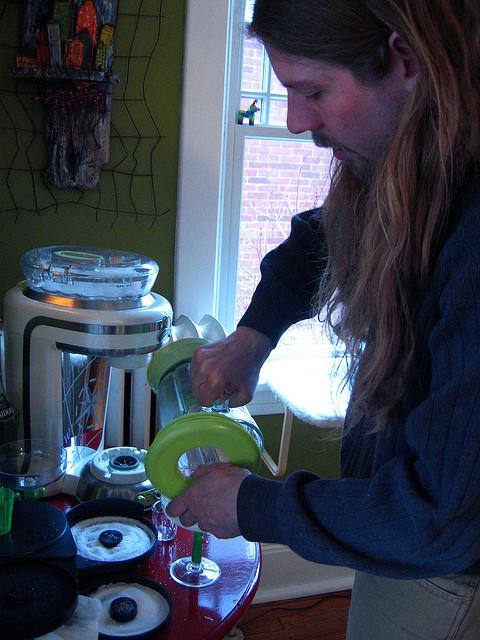Is the man's hair long enough to be put in a ponytail?
Give a very brief answer. Yes. Is the man holding a blender?
Quick response, please. Yes. What kind of wall is outside the window?
Quick response, please. Brick. 